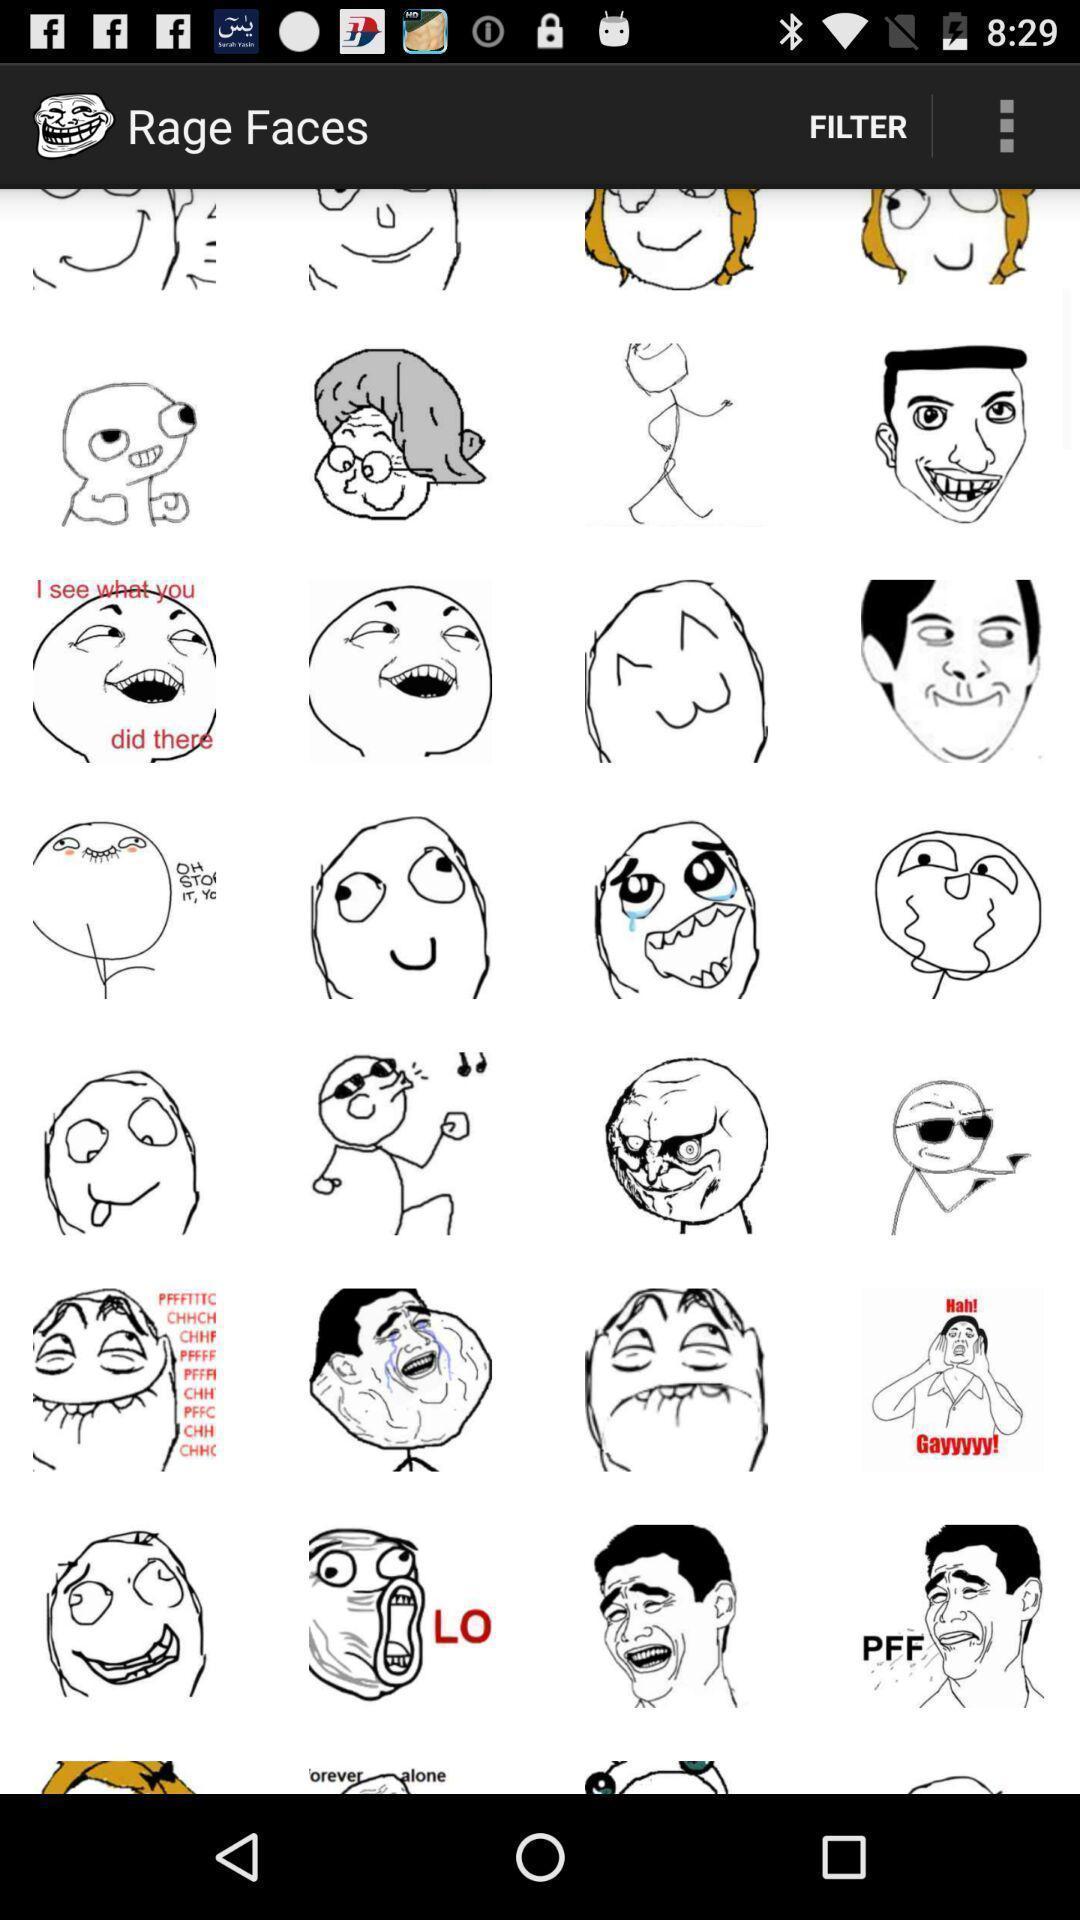Summarize the main components in this picture. Various face logos displayed of a fun interactive app. 